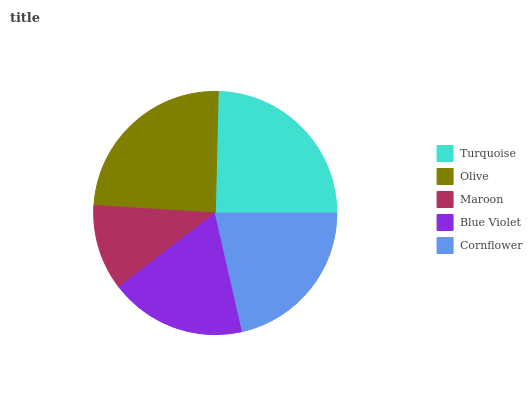Is Maroon the minimum?
Answer yes or no. Yes. Is Turquoise the maximum?
Answer yes or no. Yes. Is Olive the minimum?
Answer yes or no. No. Is Olive the maximum?
Answer yes or no. No. Is Turquoise greater than Olive?
Answer yes or no. Yes. Is Olive less than Turquoise?
Answer yes or no. Yes. Is Olive greater than Turquoise?
Answer yes or no. No. Is Turquoise less than Olive?
Answer yes or no. No. Is Cornflower the high median?
Answer yes or no. Yes. Is Cornflower the low median?
Answer yes or no. Yes. Is Maroon the high median?
Answer yes or no. No. Is Turquoise the low median?
Answer yes or no. No. 